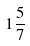<formula> <loc_0><loc_0><loc_500><loc_500>1 \frac { 5 } { 7 }</formula> 